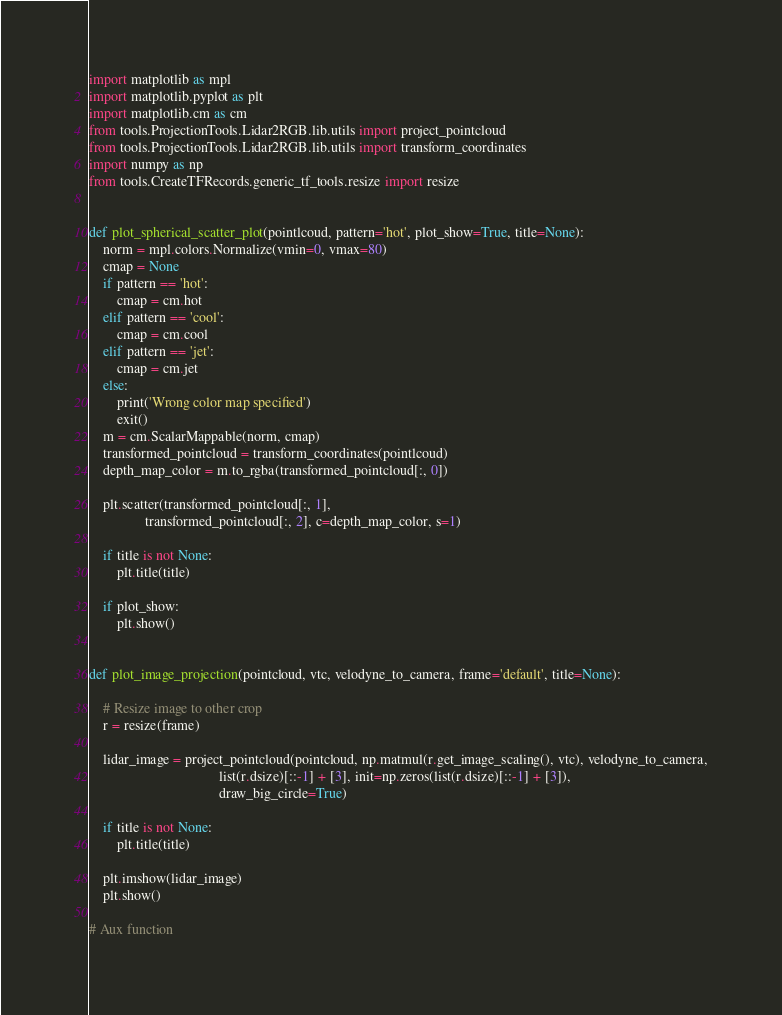Convert code to text. <code><loc_0><loc_0><loc_500><loc_500><_Python_>import matplotlib as mpl
import matplotlib.pyplot as plt
import matplotlib.cm as cm
from tools.ProjectionTools.Lidar2RGB.lib.utils import project_pointcloud
from tools.ProjectionTools.Lidar2RGB.lib.utils import transform_coordinates
import numpy as np
from tools.CreateTFRecords.generic_tf_tools.resize import resize


def plot_spherical_scatter_plot(pointlcoud, pattern='hot', plot_show=True, title=None):
    norm = mpl.colors.Normalize(vmin=0, vmax=80)
    cmap = None
    if pattern == 'hot':
        cmap = cm.hot
    elif pattern == 'cool':
        cmap = cm.cool
    elif pattern == 'jet':
        cmap = cm.jet
    else:
        print('Wrong color map specified')
        exit()
    m = cm.ScalarMappable(norm, cmap)
    transformed_pointcloud = transform_coordinates(pointlcoud)
    depth_map_color = m.to_rgba(transformed_pointcloud[:, 0])

    plt.scatter(transformed_pointcloud[:, 1],
                transformed_pointcloud[:, 2], c=depth_map_color, s=1)

    if title is not None:
        plt.title(title)

    if plot_show:
        plt.show()


def plot_image_projection(pointcloud, vtc, velodyne_to_camera, frame='default', title=None):

    # Resize image to other crop
    r = resize(frame)

    lidar_image = project_pointcloud(pointcloud, np.matmul(r.get_image_scaling(), vtc), velodyne_to_camera,
                                     list(r.dsize)[::-1] + [3], init=np.zeros(list(r.dsize)[::-1] + [3]),
                                     draw_big_circle=True)

    if title is not None:
        plt.title(title)

    plt.imshow(lidar_image)
    plt.show()

# Aux function</code> 